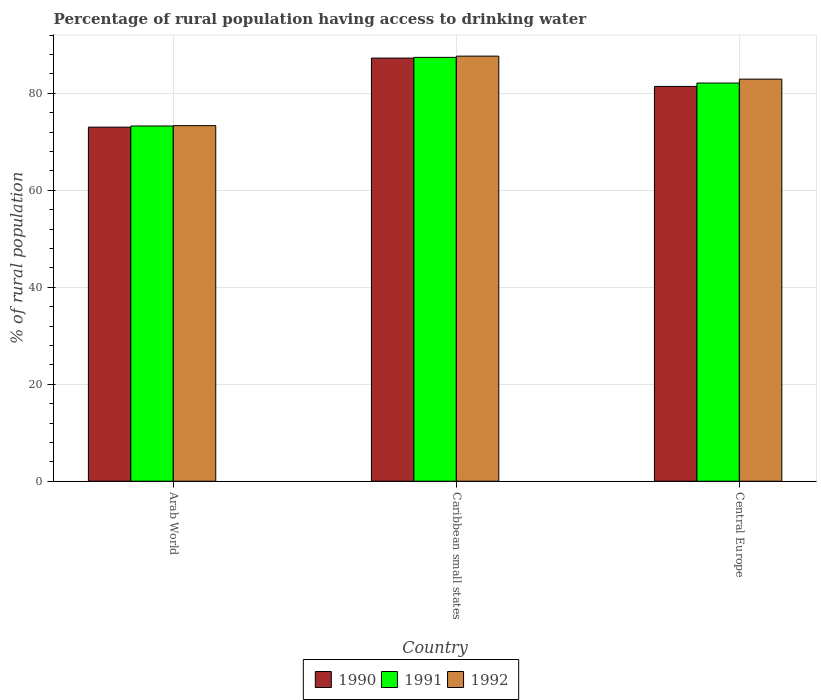Are the number of bars on each tick of the X-axis equal?
Keep it short and to the point. Yes. How many bars are there on the 1st tick from the left?
Give a very brief answer. 3. How many bars are there on the 3rd tick from the right?
Provide a short and direct response. 3. What is the label of the 3rd group of bars from the left?
Your response must be concise. Central Europe. In how many cases, is the number of bars for a given country not equal to the number of legend labels?
Make the answer very short. 0. What is the percentage of rural population having access to drinking water in 1990 in Caribbean small states?
Keep it short and to the point. 87.24. Across all countries, what is the maximum percentage of rural population having access to drinking water in 1992?
Make the answer very short. 87.64. Across all countries, what is the minimum percentage of rural population having access to drinking water in 1990?
Offer a terse response. 73. In which country was the percentage of rural population having access to drinking water in 1990 maximum?
Ensure brevity in your answer.  Caribbean small states. In which country was the percentage of rural population having access to drinking water in 1992 minimum?
Ensure brevity in your answer.  Arab World. What is the total percentage of rural population having access to drinking water in 1992 in the graph?
Your answer should be very brief. 243.86. What is the difference between the percentage of rural population having access to drinking water in 1992 in Caribbean small states and that in Central Europe?
Your response must be concise. 4.74. What is the difference between the percentage of rural population having access to drinking water in 1991 in Caribbean small states and the percentage of rural population having access to drinking water in 1992 in Arab World?
Offer a terse response. 14.08. What is the average percentage of rural population having access to drinking water in 1991 per country?
Offer a terse response. 80.91. What is the difference between the percentage of rural population having access to drinking water of/in 1990 and percentage of rural population having access to drinking water of/in 1992 in Caribbean small states?
Provide a short and direct response. -0.4. In how many countries, is the percentage of rural population having access to drinking water in 1991 greater than 40 %?
Ensure brevity in your answer.  3. What is the ratio of the percentage of rural population having access to drinking water in 1990 in Arab World to that in Central Europe?
Ensure brevity in your answer.  0.9. Is the percentage of rural population having access to drinking water in 1990 in Arab World less than that in Caribbean small states?
Provide a succinct answer. Yes. Is the difference between the percentage of rural population having access to drinking water in 1990 in Arab World and Caribbean small states greater than the difference between the percentage of rural population having access to drinking water in 1992 in Arab World and Caribbean small states?
Your answer should be compact. Yes. What is the difference between the highest and the second highest percentage of rural population having access to drinking water in 1992?
Give a very brief answer. -9.59. What is the difference between the highest and the lowest percentage of rural population having access to drinking water in 1992?
Make the answer very short. 14.33. In how many countries, is the percentage of rural population having access to drinking water in 1992 greater than the average percentage of rural population having access to drinking water in 1992 taken over all countries?
Give a very brief answer. 2. Is the sum of the percentage of rural population having access to drinking water in 1992 in Caribbean small states and Central Europe greater than the maximum percentage of rural population having access to drinking water in 1991 across all countries?
Give a very brief answer. Yes. What does the 3rd bar from the right in Central Europe represents?
Your answer should be compact. 1990. Is it the case that in every country, the sum of the percentage of rural population having access to drinking water in 1992 and percentage of rural population having access to drinking water in 1990 is greater than the percentage of rural population having access to drinking water in 1991?
Make the answer very short. Yes. How many bars are there?
Your answer should be compact. 9. How many countries are there in the graph?
Provide a succinct answer. 3. What is the difference between two consecutive major ticks on the Y-axis?
Give a very brief answer. 20. Does the graph contain grids?
Provide a short and direct response. Yes. What is the title of the graph?
Provide a succinct answer. Percentage of rural population having access to drinking water. What is the label or title of the Y-axis?
Ensure brevity in your answer.  % of rural population. What is the % of rural population of 1990 in Arab World?
Your answer should be very brief. 73. What is the % of rural population in 1991 in Arab World?
Your response must be concise. 73.24. What is the % of rural population in 1992 in Arab World?
Give a very brief answer. 73.31. What is the % of rural population in 1990 in Caribbean small states?
Ensure brevity in your answer.  87.24. What is the % of rural population of 1991 in Caribbean small states?
Offer a terse response. 87.39. What is the % of rural population of 1992 in Caribbean small states?
Ensure brevity in your answer.  87.64. What is the % of rural population of 1990 in Central Europe?
Your answer should be compact. 81.4. What is the % of rural population of 1991 in Central Europe?
Ensure brevity in your answer.  82.1. What is the % of rural population of 1992 in Central Europe?
Offer a terse response. 82.9. Across all countries, what is the maximum % of rural population of 1990?
Your answer should be very brief. 87.24. Across all countries, what is the maximum % of rural population of 1991?
Provide a succinct answer. 87.39. Across all countries, what is the maximum % of rural population in 1992?
Offer a terse response. 87.64. Across all countries, what is the minimum % of rural population in 1990?
Your answer should be compact. 73. Across all countries, what is the minimum % of rural population in 1991?
Your answer should be compact. 73.24. Across all countries, what is the minimum % of rural population in 1992?
Provide a short and direct response. 73.31. What is the total % of rural population of 1990 in the graph?
Your response must be concise. 241.65. What is the total % of rural population of 1991 in the graph?
Provide a short and direct response. 242.72. What is the total % of rural population of 1992 in the graph?
Your answer should be compact. 243.86. What is the difference between the % of rural population in 1990 in Arab World and that in Caribbean small states?
Your response must be concise. -14.24. What is the difference between the % of rural population of 1991 in Arab World and that in Caribbean small states?
Provide a short and direct response. -14.15. What is the difference between the % of rural population in 1992 in Arab World and that in Caribbean small states?
Offer a terse response. -14.33. What is the difference between the % of rural population of 1990 in Arab World and that in Central Europe?
Offer a terse response. -8.4. What is the difference between the % of rural population of 1991 in Arab World and that in Central Europe?
Offer a terse response. -8.86. What is the difference between the % of rural population of 1992 in Arab World and that in Central Europe?
Offer a terse response. -9.59. What is the difference between the % of rural population in 1990 in Caribbean small states and that in Central Europe?
Your response must be concise. 5.84. What is the difference between the % of rural population of 1991 in Caribbean small states and that in Central Europe?
Offer a terse response. 5.29. What is the difference between the % of rural population of 1992 in Caribbean small states and that in Central Europe?
Offer a very short reply. 4.74. What is the difference between the % of rural population of 1990 in Arab World and the % of rural population of 1991 in Caribbean small states?
Provide a succinct answer. -14.38. What is the difference between the % of rural population of 1990 in Arab World and the % of rural population of 1992 in Caribbean small states?
Offer a terse response. -14.64. What is the difference between the % of rural population of 1991 in Arab World and the % of rural population of 1992 in Caribbean small states?
Keep it short and to the point. -14.41. What is the difference between the % of rural population of 1990 in Arab World and the % of rural population of 1991 in Central Europe?
Provide a succinct answer. -9.09. What is the difference between the % of rural population in 1990 in Arab World and the % of rural population in 1992 in Central Europe?
Keep it short and to the point. -9.9. What is the difference between the % of rural population of 1991 in Arab World and the % of rural population of 1992 in Central Europe?
Offer a very short reply. -9.66. What is the difference between the % of rural population in 1990 in Caribbean small states and the % of rural population in 1991 in Central Europe?
Ensure brevity in your answer.  5.14. What is the difference between the % of rural population in 1990 in Caribbean small states and the % of rural population in 1992 in Central Europe?
Give a very brief answer. 4.34. What is the difference between the % of rural population of 1991 in Caribbean small states and the % of rural population of 1992 in Central Europe?
Keep it short and to the point. 4.49. What is the average % of rural population of 1990 per country?
Keep it short and to the point. 80.55. What is the average % of rural population in 1991 per country?
Your answer should be compact. 80.91. What is the average % of rural population in 1992 per country?
Ensure brevity in your answer.  81.28. What is the difference between the % of rural population in 1990 and % of rural population in 1991 in Arab World?
Provide a succinct answer. -0.23. What is the difference between the % of rural population of 1990 and % of rural population of 1992 in Arab World?
Keep it short and to the point. -0.31. What is the difference between the % of rural population in 1991 and % of rural population in 1992 in Arab World?
Give a very brief answer. -0.07. What is the difference between the % of rural population of 1990 and % of rural population of 1991 in Caribbean small states?
Ensure brevity in your answer.  -0.15. What is the difference between the % of rural population in 1990 and % of rural population in 1992 in Caribbean small states?
Make the answer very short. -0.4. What is the difference between the % of rural population in 1991 and % of rural population in 1992 in Caribbean small states?
Give a very brief answer. -0.26. What is the difference between the % of rural population in 1990 and % of rural population in 1991 in Central Europe?
Keep it short and to the point. -0.69. What is the difference between the % of rural population in 1990 and % of rural population in 1992 in Central Europe?
Keep it short and to the point. -1.5. What is the difference between the % of rural population in 1991 and % of rural population in 1992 in Central Europe?
Your response must be concise. -0.8. What is the ratio of the % of rural population in 1990 in Arab World to that in Caribbean small states?
Keep it short and to the point. 0.84. What is the ratio of the % of rural population of 1991 in Arab World to that in Caribbean small states?
Ensure brevity in your answer.  0.84. What is the ratio of the % of rural population of 1992 in Arab World to that in Caribbean small states?
Your answer should be very brief. 0.84. What is the ratio of the % of rural population of 1990 in Arab World to that in Central Europe?
Make the answer very short. 0.9. What is the ratio of the % of rural population of 1991 in Arab World to that in Central Europe?
Ensure brevity in your answer.  0.89. What is the ratio of the % of rural population of 1992 in Arab World to that in Central Europe?
Your response must be concise. 0.88. What is the ratio of the % of rural population of 1990 in Caribbean small states to that in Central Europe?
Offer a terse response. 1.07. What is the ratio of the % of rural population of 1991 in Caribbean small states to that in Central Europe?
Make the answer very short. 1.06. What is the ratio of the % of rural population of 1992 in Caribbean small states to that in Central Europe?
Provide a short and direct response. 1.06. What is the difference between the highest and the second highest % of rural population of 1990?
Offer a very short reply. 5.84. What is the difference between the highest and the second highest % of rural population of 1991?
Your response must be concise. 5.29. What is the difference between the highest and the second highest % of rural population of 1992?
Ensure brevity in your answer.  4.74. What is the difference between the highest and the lowest % of rural population of 1990?
Ensure brevity in your answer.  14.24. What is the difference between the highest and the lowest % of rural population of 1991?
Offer a terse response. 14.15. What is the difference between the highest and the lowest % of rural population of 1992?
Offer a terse response. 14.33. 